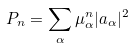Convert formula to latex. <formula><loc_0><loc_0><loc_500><loc_500>P _ { n } = \sum _ { \alpha } \mu _ { \alpha } ^ { n } | a _ { \alpha } | ^ { 2 }</formula> 